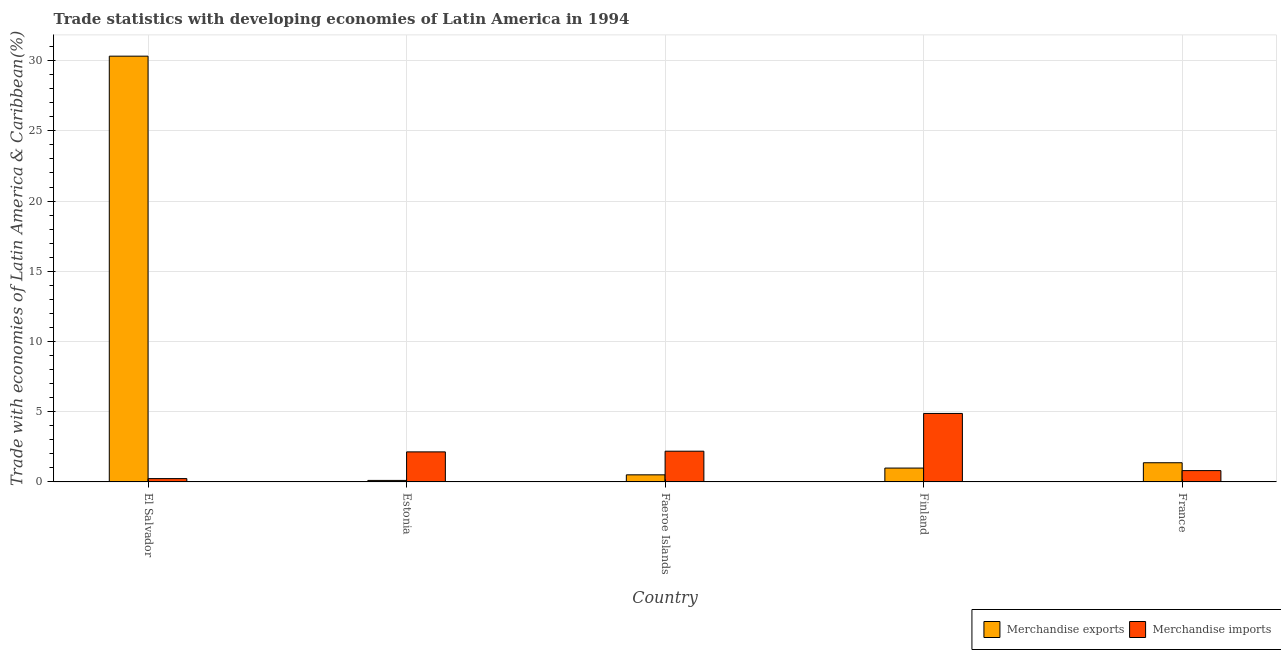Are the number of bars per tick equal to the number of legend labels?
Your answer should be compact. Yes. Are the number of bars on each tick of the X-axis equal?
Provide a short and direct response. Yes. How many bars are there on the 2nd tick from the left?
Offer a terse response. 2. What is the label of the 2nd group of bars from the left?
Offer a very short reply. Estonia. In how many cases, is the number of bars for a given country not equal to the number of legend labels?
Provide a succinct answer. 0. What is the merchandise exports in Finland?
Give a very brief answer. 0.99. Across all countries, what is the maximum merchandise imports?
Your response must be concise. 4.88. Across all countries, what is the minimum merchandise exports?
Give a very brief answer. 0.11. In which country was the merchandise exports maximum?
Your answer should be very brief. El Salvador. In which country was the merchandise imports minimum?
Your response must be concise. El Salvador. What is the total merchandise exports in the graph?
Your answer should be compact. 33.28. What is the difference between the merchandise exports in El Salvador and that in Finland?
Your answer should be very brief. 29.33. What is the difference between the merchandise imports in Estonia and the merchandise exports in Finland?
Offer a terse response. 1.15. What is the average merchandise exports per country?
Your response must be concise. 6.66. What is the difference between the merchandise imports and merchandise exports in Faeroe Islands?
Provide a short and direct response. 1.68. What is the ratio of the merchandise imports in El Salvador to that in France?
Your answer should be compact. 0.29. Is the difference between the merchandise imports in Estonia and Finland greater than the difference between the merchandise exports in Estonia and Finland?
Your answer should be compact. No. What is the difference between the highest and the second highest merchandise imports?
Keep it short and to the point. 2.69. What is the difference between the highest and the lowest merchandise exports?
Offer a terse response. 30.21. What does the 1st bar from the right in Finland represents?
Give a very brief answer. Merchandise imports. Are all the bars in the graph horizontal?
Offer a terse response. No. How many countries are there in the graph?
Your response must be concise. 5. What is the difference between two consecutive major ticks on the Y-axis?
Your answer should be very brief. 5. Does the graph contain grids?
Your response must be concise. Yes. Where does the legend appear in the graph?
Give a very brief answer. Bottom right. How are the legend labels stacked?
Make the answer very short. Horizontal. What is the title of the graph?
Your answer should be very brief. Trade statistics with developing economies of Latin America in 1994. What is the label or title of the X-axis?
Offer a very short reply. Country. What is the label or title of the Y-axis?
Offer a terse response. Trade with economies of Latin America & Caribbean(%). What is the Trade with economies of Latin America & Caribbean(%) of Merchandise exports in El Salvador?
Provide a short and direct response. 30.32. What is the Trade with economies of Latin America & Caribbean(%) in Merchandise imports in El Salvador?
Offer a terse response. 0.24. What is the Trade with economies of Latin America & Caribbean(%) of Merchandise exports in Estonia?
Provide a short and direct response. 0.11. What is the Trade with economies of Latin America & Caribbean(%) of Merchandise imports in Estonia?
Your answer should be very brief. 2.14. What is the Trade with economies of Latin America & Caribbean(%) in Merchandise exports in Faeroe Islands?
Keep it short and to the point. 0.5. What is the Trade with economies of Latin America & Caribbean(%) in Merchandise imports in Faeroe Islands?
Give a very brief answer. 2.19. What is the Trade with economies of Latin America & Caribbean(%) in Merchandise exports in Finland?
Your response must be concise. 0.99. What is the Trade with economies of Latin America & Caribbean(%) in Merchandise imports in Finland?
Keep it short and to the point. 4.88. What is the Trade with economies of Latin America & Caribbean(%) of Merchandise exports in France?
Your answer should be compact. 1.37. What is the Trade with economies of Latin America & Caribbean(%) of Merchandise imports in France?
Your answer should be very brief. 0.81. Across all countries, what is the maximum Trade with economies of Latin America & Caribbean(%) of Merchandise exports?
Give a very brief answer. 30.32. Across all countries, what is the maximum Trade with economies of Latin America & Caribbean(%) of Merchandise imports?
Keep it short and to the point. 4.88. Across all countries, what is the minimum Trade with economies of Latin America & Caribbean(%) of Merchandise exports?
Your answer should be compact. 0.11. Across all countries, what is the minimum Trade with economies of Latin America & Caribbean(%) of Merchandise imports?
Offer a very short reply. 0.24. What is the total Trade with economies of Latin America & Caribbean(%) in Merchandise exports in the graph?
Give a very brief answer. 33.28. What is the total Trade with economies of Latin America & Caribbean(%) of Merchandise imports in the graph?
Offer a very short reply. 10.24. What is the difference between the Trade with economies of Latin America & Caribbean(%) of Merchandise exports in El Salvador and that in Estonia?
Your answer should be very brief. 30.21. What is the difference between the Trade with economies of Latin America & Caribbean(%) in Merchandise imports in El Salvador and that in Estonia?
Your response must be concise. -1.9. What is the difference between the Trade with economies of Latin America & Caribbean(%) in Merchandise exports in El Salvador and that in Faeroe Islands?
Keep it short and to the point. 29.81. What is the difference between the Trade with economies of Latin America & Caribbean(%) in Merchandise imports in El Salvador and that in Faeroe Islands?
Your response must be concise. -1.95. What is the difference between the Trade with economies of Latin America & Caribbean(%) in Merchandise exports in El Salvador and that in Finland?
Give a very brief answer. 29.33. What is the difference between the Trade with economies of Latin America & Caribbean(%) in Merchandise imports in El Salvador and that in Finland?
Provide a succinct answer. -4.64. What is the difference between the Trade with economies of Latin America & Caribbean(%) in Merchandise exports in El Salvador and that in France?
Your response must be concise. 28.95. What is the difference between the Trade with economies of Latin America & Caribbean(%) of Merchandise imports in El Salvador and that in France?
Your answer should be compact. -0.57. What is the difference between the Trade with economies of Latin America & Caribbean(%) in Merchandise exports in Estonia and that in Faeroe Islands?
Offer a very short reply. -0.4. What is the difference between the Trade with economies of Latin America & Caribbean(%) in Merchandise imports in Estonia and that in Faeroe Islands?
Provide a short and direct response. -0.05. What is the difference between the Trade with economies of Latin America & Caribbean(%) of Merchandise exports in Estonia and that in Finland?
Give a very brief answer. -0.88. What is the difference between the Trade with economies of Latin America & Caribbean(%) in Merchandise imports in Estonia and that in Finland?
Provide a succinct answer. -2.74. What is the difference between the Trade with economies of Latin America & Caribbean(%) of Merchandise exports in Estonia and that in France?
Your answer should be compact. -1.26. What is the difference between the Trade with economies of Latin America & Caribbean(%) in Merchandise imports in Estonia and that in France?
Your answer should be compact. 1.33. What is the difference between the Trade with economies of Latin America & Caribbean(%) in Merchandise exports in Faeroe Islands and that in Finland?
Ensure brevity in your answer.  -0.48. What is the difference between the Trade with economies of Latin America & Caribbean(%) in Merchandise imports in Faeroe Islands and that in Finland?
Your response must be concise. -2.69. What is the difference between the Trade with economies of Latin America & Caribbean(%) in Merchandise exports in Faeroe Islands and that in France?
Ensure brevity in your answer.  -0.86. What is the difference between the Trade with economies of Latin America & Caribbean(%) in Merchandise imports in Faeroe Islands and that in France?
Offer a terse response. 1.38. What is the difference between the Trade with economies of Latin America & Caribbean(%) in Merchandise exports in Finland and that in France?
Your response must be concise. -0.38. What is the difference between the Trade with economies of Latin America & Caribbean(%) of Merchandise imports in Finland and that in France?
Offer a terse response. 4.07. What is the difference between the Trade with economies of Latin America & Caribbean(%) of Merchandise exports in El Salvador and the Trade with economies of Latin America & Caribbean(%) of Merchandise imports in Estonia?
Keep it short and to the point. 28.18. What is the difference between the Trade with economies of Latin America & Caribbean(%) in Merchandise exports in El Salvador and the Trade with economies of Latin America & Caribbean(%) in Merchandise imports in Faeroe Islands?
Ensure brevity in your answer.  28.13. What is the difference between the Trade with economies of Latin America & Caribbean(%) of Merchandise exports in El Salvador and the Trade with economies of Latin America & Caribbean(%) of Merchandise imports in Finland?
Make the answer very short. 25.44. What is the difference between the Trade with economies of Latin America & Caribbean(%) in Merchandise exports in El Salvador and the Trade with economies of Latin America & Caribbean(%) in Merchandise imports in France?
Your response must be concise. 29.51. What is the difference between the Trade with economies of Latin America & Caribbean(%) in Merchandise exports in Estonia and the Trade with economies of Latin America & Caribbean(%) in Merchandise imports in Faeroe Islands?
Your answer should be compact. -2.08. What is the difference between the Trade with economies of Latin America & Caribbean(%) of Merchandise exports in Estonia and the Trade with economies of Latin America & Caribbean(%) of Merchandise imports in Finland?
Make the answer very short. -4.77. What is the difference between the Trade with economies of Latin America & Caribbean(%) in Merchandise exports in Estonia and the Trade with economies of Latin America & Caribbean(%) in Merchandise imports in France?
Your response must be concise. -0.7. What is the difference between the Trade with economies of Latin America & Caribbean(%) of Merchandise exports in Faeroe Islands and the Trade with economies of Latin America & Caribbean(%) of Merchandise imports in Finland?
Your answer should be compact. -4.37. What is the difference between the Trade with economies of Latin America & Caribbean(%) in Merchandise exports in Faeroe Islands and the Trade with economies of Latin America & Caribbean(%) in Merchandise imports in France?
Give a very brief answer. -0.3. What is the difference between the Trade with economies of Latin America & Caribbean(%) of Merchandise exports in Finland and the Trade with economies of Latin America & Caribbean(%) of Merchandise imports in France?
Offer a very short reply. 0.18. What is the average Trade with economies of Latin America & Caribbean(%) of Merchandise exports per country?
Give a very brief answer. 6.66. What is the average Trade with economies of Latin America & Caribbean(%) in Merchandise imports per country?
Offer a terse response. 2.05. What is the difference between the Trade with economies of Latin America & Caribbean(%) of Merchandise exports and Trade with economies of Latin America & Caribbean(%) of Merchandise imports in El Salvador?
Keep it short and to the point. 30.08. What is the difference between the Trade with economies of Latin America & Caribbean(%) of Merchandise exports and Trade with economies of Latin America & Caribbean(%) of Merchandise imports in Estonia?
Make the answer very short. -2.03. What is the difference between the Trade with economies of Latin America & Caribbean(%) in Merchandise exports and Trade with economies of Latin America & Caribbean(%) in Merchandise imports in Faeroe Islands?
Offer a very short reply. -1.68. What is the difference between the Trade with economies of Latin America & Caribbean(%) of Merchandise exports and Trade with economies of Latin America & Caribbean(%) of Merchandise imports in Finland?
Keep it short and to the point. -3.89. What is the difference between the Trade with economies of Latin America & Caribbean(%) in Merchandise exports and Trade with economies of Latin America & Caribbean(%) in Merchandise imports in France?
Provide a short and direct response. 0.56. What is the ratio of the Trade with economies of Latin America & Caribbean(%) in Merchandise exports in El Salvador to that in Estonia?
Provide a short and direct response. 284.74. What is the ratio of the Trade with economies of Latin America & Caribbean(%) of Merchandise imports in El Salvador to that in Estonia?
Your answer should be compact. 0.11. What is the ratio of the Trade with economies of Latin America & Caribbean(%) of Merchandise exports in El Salvador to that in Faeroe Islands?
Make the answer very short. 60.09. What is the ratio of the Trade with economies of Latin America & Caribbean(%) of Merchandise imports in El Salvador to that in Faeroe Islands?
Your answer should be compact. 0.11. What is the ratio of the Trade with economies of Latin America & Caribbean(%) of Merchandise exports in El Salvador to that in Finland?
Provide a succinct answer. 30.76. What is the ratio of the Trade with economies of Latin America & Caribbean(%) of Merchandise imports in El Salvador to that in Finland?
Provide a short and direct response. 0.05. What is the ratio of the Trade with economies of Latin America & Caribbean(%) of Merchandise exports in El Salvador to that in France?
Provide a short and direct response. 22.21. What is the ratio of the Trade with economies of Latin America & Caribbean(%) of Merchandise imports in El Salvador to that in France?
Ensure brevity in your answer.  0.29. What is the ratio of the Trade with economies of Latin America & Caribbean(%) of Merchandise exports in Estonia to that in Faeroe Islands?
Keep it short and to the point. 0.21. What is the ratio of the Trade with economies of Latin America & Caribbean(%) in Merchandise imports in Estonia to that in Faeroe Islands?
Provide a succinct answer. 0.98. What is the ratio of the Trade with economies of Latin America & Caribbean(%) in Merchandise exports in Estonia to that in Finland?
Provide a succinct answer. 0.11. What is the ratio of the Trade with economies of Latin America & Caribbean(%) in Merchandise imports in Estonia to that in Finland?
Give a very brief answer. 0.44. What is the ratio of the Trade with economies of Latin America & Caribbean(%) in Merchandise exports in Estonia to that in France?
Provide a short and direct response. 0.08. What is the ratio of the Trade with economies of Latin America & Caribbean(%) in Merchandise imports in Estonia to that in France?
Provide a short and direct response. 2.65. What is the ratio of the Trade with economies of Latin America & Caribbean(%) in Merchandise exports in Faeroe Islands to that in Finland?
Offer a terse response. 0.51. What is the ratio of the Trade with economies of Latin America & Caribbean(%) of Merchandise imports in Faeroe Islands to that in Finland?
Provide a short and direct response. 0.45. What is the ratio of the Trade with economies of Latin America & Caribbean(%) of Merchandise exports in Faeroe Islands to that in France?
Offer a very short reply. 0.37. What is the ratio of the Trade with economies of Latin America & Caribbean(%) in Merchandise imports in Faeroe Islands to that in France?
Provide a succinct answer. 2.71. What is the ratio of the Trade with economies of Latin America & Caribbean(%) of Merchandise exports in Finland to that in France?
Keep it short and to the point. 0.72. What is the ratio of the Trade with economies of Latin America & Caribbean(%) in Merchandise imports in Finland to that in France?
Give a very brief answer. 6.05. What is the difference between the highest and the second highest Trade with economies of Latin America & Caribbean(%) in Merchandise exports?
Give a very brief answer. 28.95. What is the difference between the highest and the second highest Trade with economies of Latin America & Caribbean(%) of Merchandise imports?
Your answer should be very brief. 2.69. What is the difference between the highest and the lowest Trade with economies of Latin America & Caribbean(%) of Merchandise exports?
Give a very brief answer. 30.21. What is the difference between the highest and the lowest Trade with economies of Latin America & Caribbean(%) of Merchandise imports?
Make the answer very short. 4.64. 